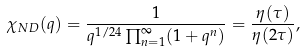Convert formula to latex. <formula><loc_0><loc_0><loc_500><loc_500>\chi _ { N D } ( q ) = \frac { 1 } { q ^ { 1 / 2 4 } \prod _ { n = 1 } ^ { \infty } ( 1 + q ^ { n } ) } = \frac { \eta ( \tau ) } { \eta ( 2 \tau ) } ,</formula> 